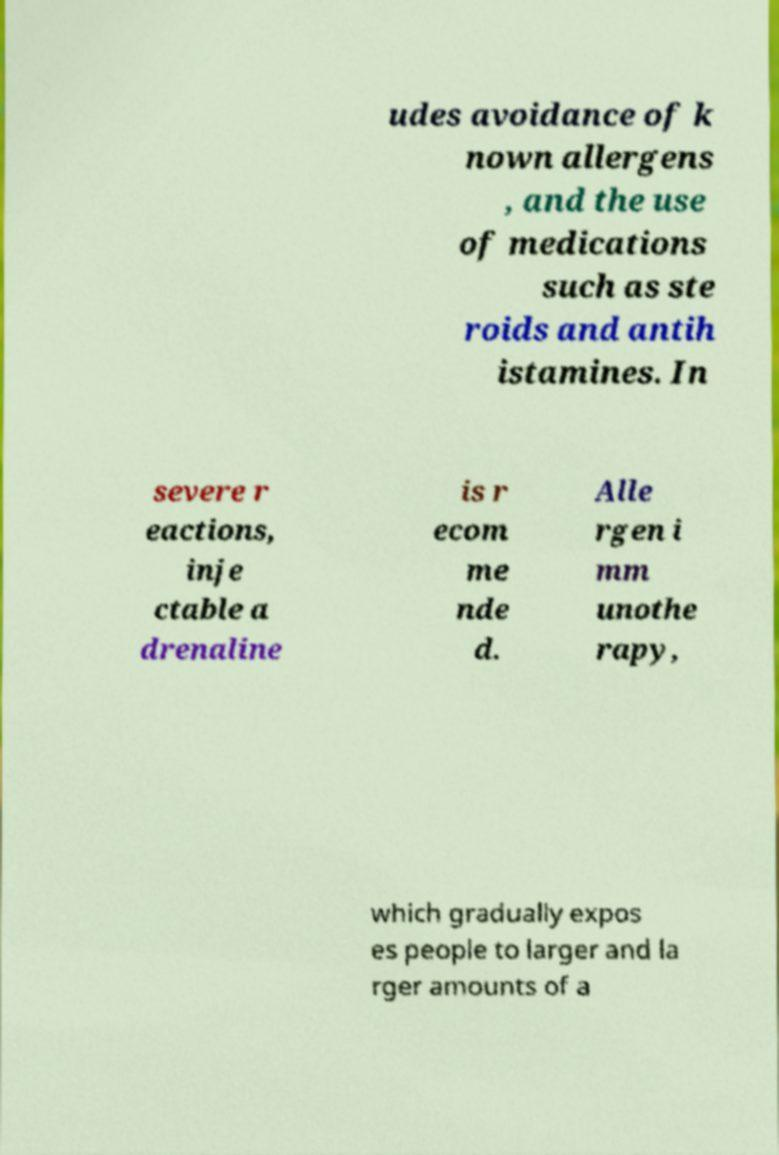I need the written content from this picture converted into text. Can you do that? udes avoidance of k nown allergens , and the use of medications such as ste roids and antih istamines. In severe r eactions, inje ctable a drenaline is r ecom me nde d. Alle rgen i mm unothe rapy, which gradually expos es people to larger and la rger amounts of a 